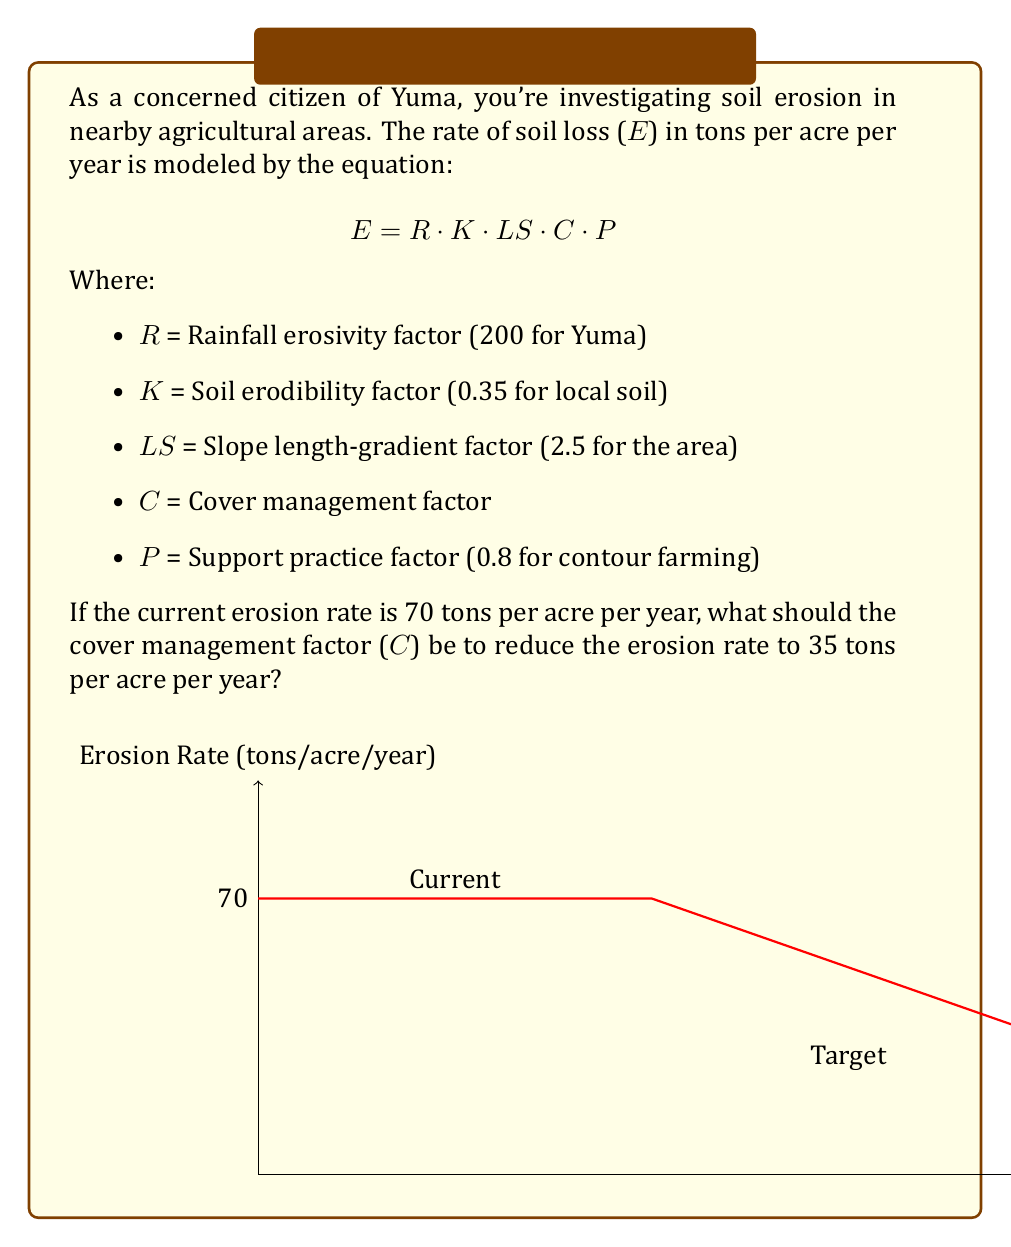Can you solve this math problem? Let's approach this step-by-step:

1) First, we'll use the given equation with the current erosion rate to find the current C value:

   $70 = 200 \cdot 0.35 \cdot 2.5 \cdot C \cdot 0.8$

2) Simplify the right side:
   
   $70 = 140 \cdot C$

3) Solve for C:
   
   $C = \frac{70}{140} = 0.5$

4) Now, we want to reduce the erosion rate to 35 tons per acre per year. Let's call the new C value $C_{new}$:

   $35 = 200 \cdot 0.35 \cdot 2.5 \cdot C_{new} \cdot 0.8$

5) Simplify:

   $35 = 140 \cdot C_{new}$

6) Solve for $C_{new}$:

   $C_{new} = \frac{35}{140} = 0.25$

Therefore, to reduce the erosion rate from 70 to 35 tons per acre per year, the cover management factor needs to be reduced from 0.5 to 0.25.
Answer: $C_{new} = 0.25$ 